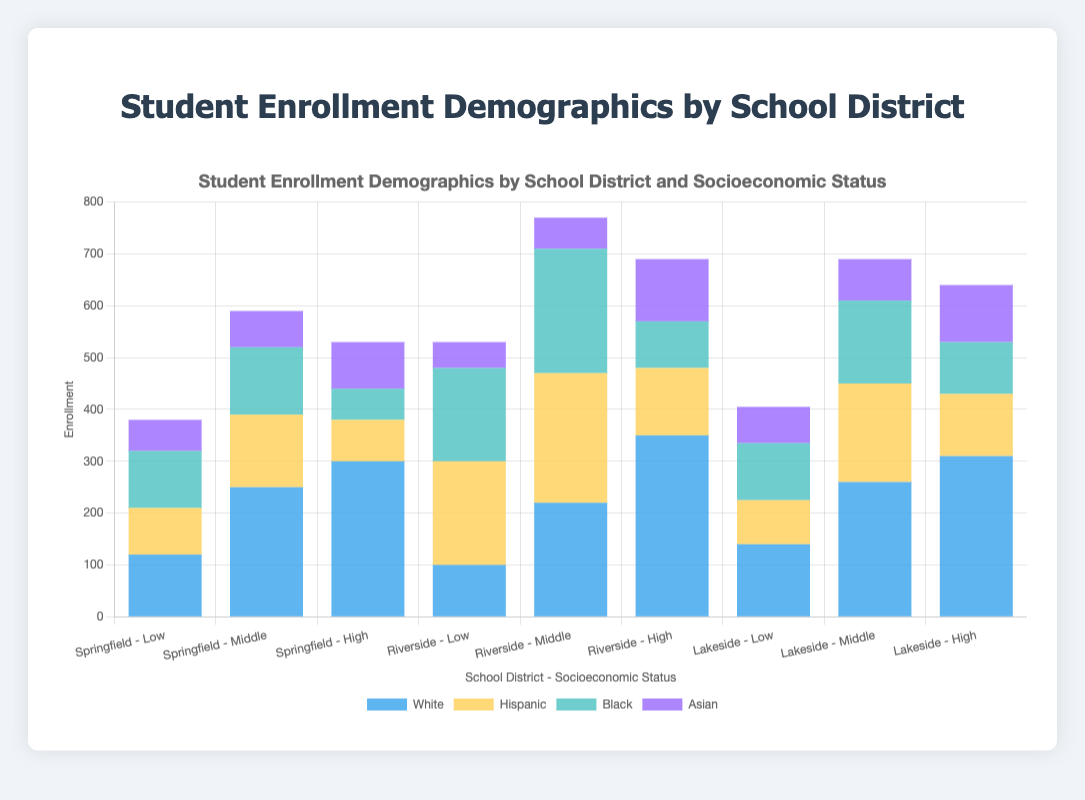Which school district has the highest total enrollment for students from low socioeconomic status? Summing up the enrollment for students from low socioeconomic status across all districts: Springfield (380), Riverside (530), Lakeside (405). Riverside has the highest total enrollment.
Answer: Riverside What is the average enrollment of Asian students across all school districts and socioeconomic statuses? Sum the enrollments of Asian students across all districts and socioeconomic statuses: Springfield (220), Riverside (230), Lakeside (260). The total is 710. There are 12 Asian data points, so the average is 710 / 12 = ~59.17.
Answer: ~59.17 Compare the enrollment of Black students in middle socioeconomic status across Springfield and Riverside. Which district has more students? In Springfield, there are 130 Black students in middle socioeconomic status. In Riverside, there are 240. Riverside has more Black students in this category.
Answer: Riverside In the Lakeside school district, which socioeconomic status has the highest enrollment of Hispanic students? In Lakeside, Hispanic student enrollments are: Low (85), Middle (190), High (120). Middle socioeconomic status has the highest enrollment of Hispanic students.
Answer: Middle What is the difference in enrollment between White and Hispanic students in the high socioeconomic status for Riverside? In Riverside, the enrollment for White students in high socioeconomic status is 350, and for Hispanic students, it is 130. The difference is 350 - 130 = 220.
Answer: 220 Which ethnicity has the least enrollment in low socioeconomic status in the Springfield district? In Springfield, low socioeconomic status enrollments are: White (120), Hispanic (90), Black (110), Asian (60). Asian students have the least enrollment.
Answer: Asian Are there more Black students in middle socioeconomic status or Asian students in high socioeconomic status in the Lakeside district? In Lakeside, there are 160 Black students in middle socioeconomic status and 110 Asian students in high socioeconomic status. There are more Black students in middle socioeconomic status.
Answer: Black students in middle socioeconomic status Considering all districts combined, how does the total enrollment of White students compare to Black students in high socioeconomic status? Summing up the enrollment of White students in high socioeconomic status across all districts: Springfield (300), Riverside (350), Lakeside (310). The total is 960. For Black students: Springfield (60), Riverside (90), Lakeside (100). The total is 250. White students have significantly more total enrollment.
Answer: White students Which school district has the lowest enrollment for Hispanic students from high socioeconomic status? Comparing the enrollments of Hispanic students from high socioeconomic status across districts: Springfield (80), Riverside (130), Lakeside (120). Springfield has the lowest enrollment.
Answer: Springfield How does the total enrollment of low socioeconomic status students in Lakeside compare to the middle socioeconomic status students in Springfield? Summing low socioeconomic status students in Lakeside: 140 (White) + 85 (Hispanic) + 110 (Black) + 70 (Asian) = 405. Summing middle socioeconomic status students in Springfield: 250 (White) + 140 (Hispanic) + 130 (Black) + 70 (Asian) = 590. Lakeside total is less than Springfield.
Answer: Less 